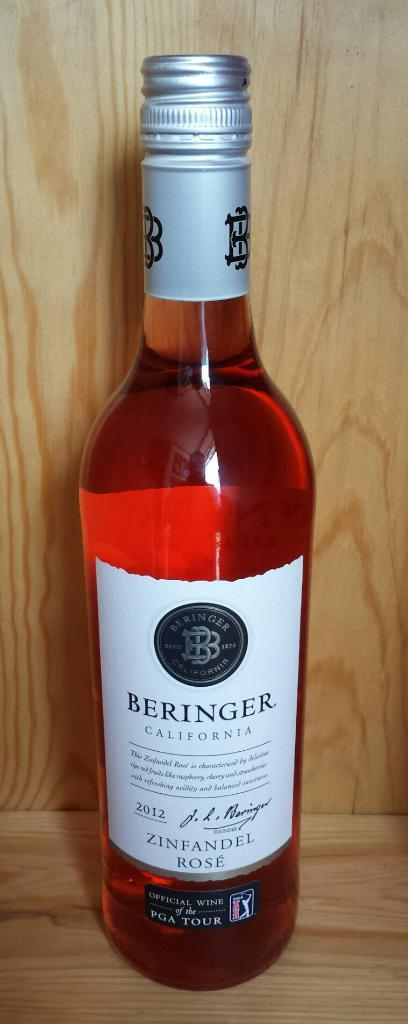<image>
Create a compact narrative representing the image presented. A bottle of Beringer California Rose Zinfandel wine 